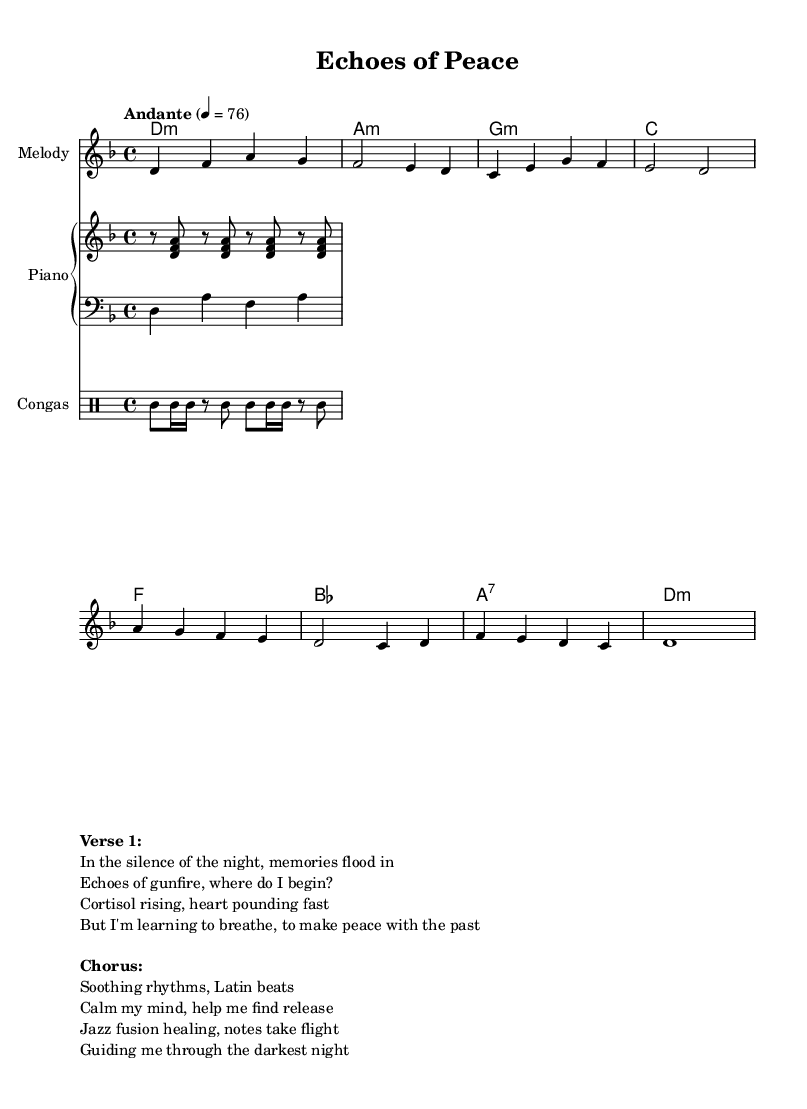What is the key signature of this music? The key signature is D minor, which has one flat (C). This is indicated in the global section under the \key directive.
Answer: D minor What is the time signature of this music? The time signature is 4/4, which is shown following the \time directive in the global section. This means there are four beats in a measure.
Answer: 4/4 What is the tempo marking for this piece? The tempo marking is "Andante," which is indicated in the global section. This tells the performer to play at a moderately slow pace.
Answer: Andante How many measures are in the melody? By counting the individual segments or bars marked by the vertical lines in the melody staff, we conclude that there are 8 measures shown here.
Answer: 8 What instruments are included in this score? The score contains a melody staff, piano staff (with both right and left hand parts), and a drum staff specifically for congas. This can be identified in the \score section.
Answer: Melody, Piano, Congas Which section contains the lyrics? The lyrics are located in the \markup section at the bottom of the code. It is labeled with "Verse 1" and "Chorus," providing a textual narrative to accompany the music.
Answer: \markup section What fusion genre is represented in this piece? The piece exemplifies Latin jazz fusion, as reflected in the title and the blending of Latin rhythms with jazz elements, as indicated by the styles in the music.
Answer: Latin jazz fusion 